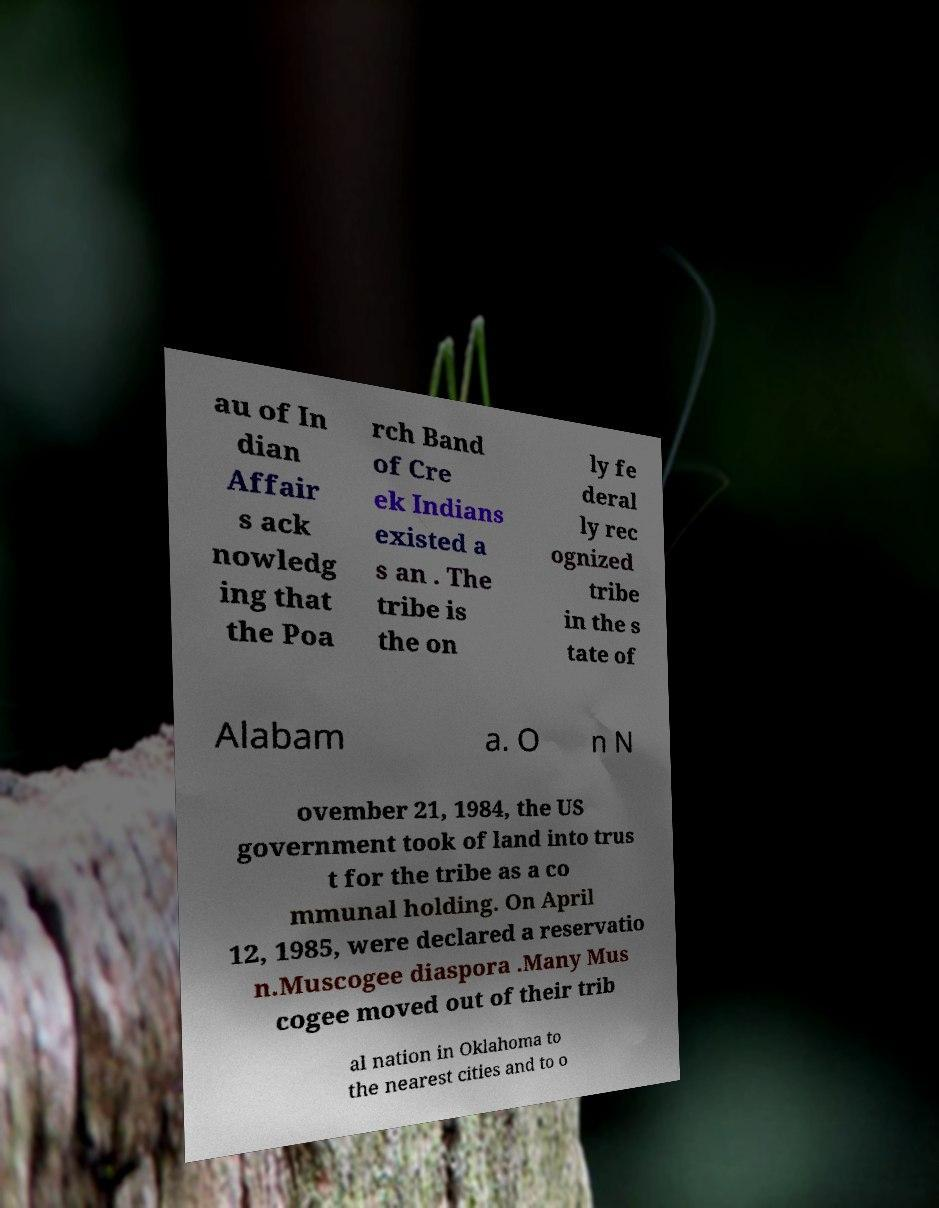Please read and relay the text visible in this image. What does it say? au of In dian Affair s ack nowledg ing that the Poa rch Band of Cre ek Indians existed a s an . The tribe is the on ly fe deral ly rec ognized tribe in the s tate of Alabam a. O n N ovember 21, 1984, the US government took of land into trus t for the tribe as a co mmunal holding. On April 12, 1985, were declared a reservatio n.Muscogee diaspora .Many Mus cogee moved out of their trib al nation in Oklahoma to the nearest cities and to o 